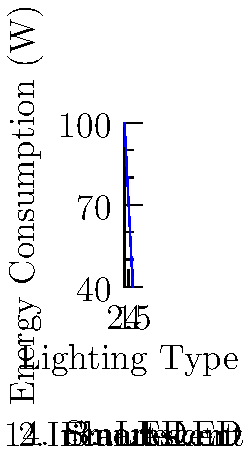As a law firm manager looking to reduce energy costs, you're considering different lighting options for your office. The graph shows the energy consumption of various lighting types. Which lighting option would be most efficient in terms of energy consumption and heat transfer, potentially reducing both electricity bills and air conditioning load? To determine the most efficient lighting option, we need to analyze the energy consumption and heat transfer characteristics of each type:

1. Incandescent bulbs (100W):
   - Highest energy consumption
   - Convert only about 10% of energy to light, 90% to heat
   - Significant heat output increases air conditioning load

2. Fluorescent lights (80W):
   - Lower energy consumption than incandescent
   - More efficient, converting about 20% of energy to light
   - Produce less heat, but still contribute to heat load

3. LED lights (60W):
   - Even lower energy consumption
   - Highly efficient, converting about 80-90% of energy to light
   - Minimal heat output, reducing air conditioning load

4. Smart LED lights (40W):
   - Lowest energy consumption
   - Same high efficiency as regular LEDs
   - Additional energy savings through automation and dimming features
   - Minimal heat output, further reducing air conditioning load

The graph clearly shows that Smart LED lights consume the least energy (40W). They also produce the least amount of heat, which means less strain on the air conditioning system. This combination of low energy consumption and minimal heat transfer makes Smart LED lighting the most efficient option for both reducing electricity bills and lowering the overall cooling load in the office.
Answer: Smart LED lights 